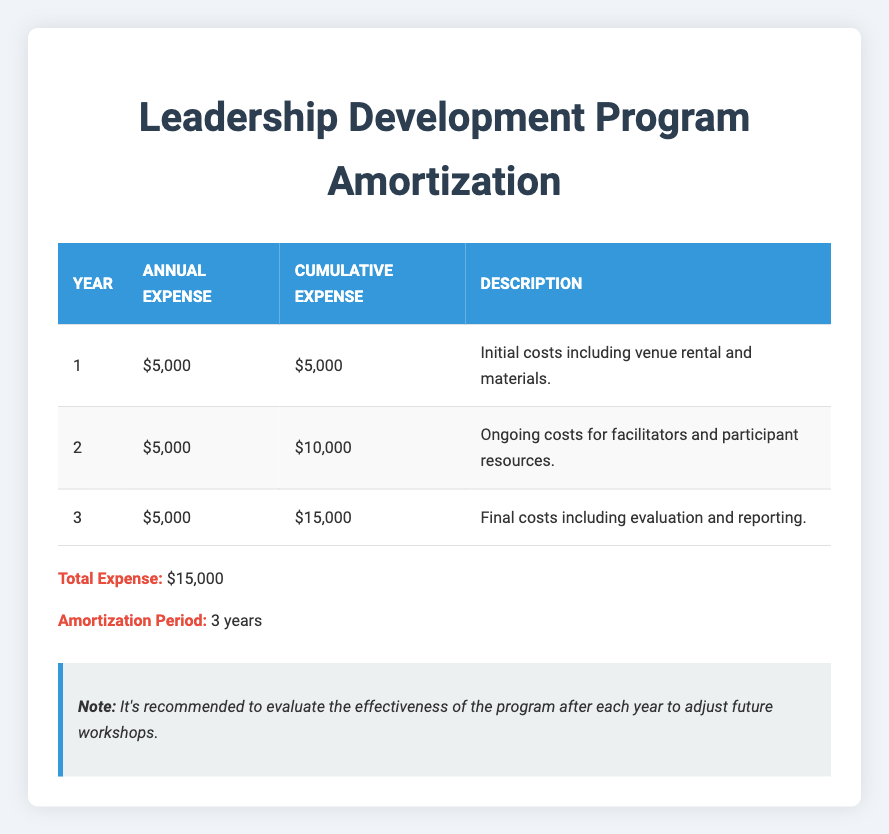What is the annual expense for the second year? The annual expense for the second year is directly shown in the table under the "Annual Expense" column for Year 2, which is $5,000.
Answer: $5,000 What is the cumulative expense at the end of year 3? The cumulative expense at the end of year 3 can be found in the "Cumulative Expense" column for Year 3, which indicates that the cumulative expense totals $15,000 by the end of the third year.
Answer: $15,000 True or False: The total expenses for the Leadership Development Program are less than $15,000. The total expenses are listed clearly as $15,000, which means the statement that they are less than $15,000 is false.
Answer: False What are the descriptions of the expenses for year 1 and year 2 combined? To find the combined description, we look at the descriptions for Years 1 and 2, which detail initial costs including venue rental and materials for Year 1, and ongoing costs for facilitators and participant resources for Year 2. Combining these would yield a summary of both initial and ongoing costs.
Answer: Initial costs including venue rental and materials; ongoing costs for facilitators and participant resources What is the average annual expense over the amortization period? The annual expense is consistent at $5,000 for each of the three years. To find the average, we can sum the annual expenses ($5,000 + $5,000 + $5,000) which totals $15,000, and then divide by the number of years (3). Thus, the average is $15,000 / 3 = $5,000.
Answer: $5,000 